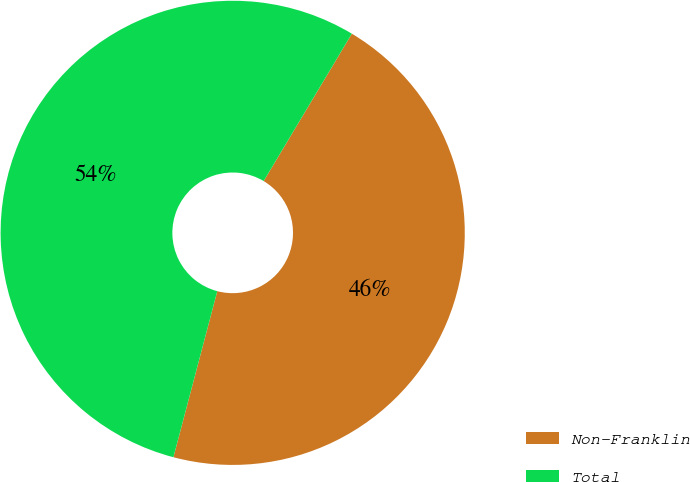<chart> <loc_0><loc_0><loc_500><loc_500><pie_chart><fcel>Non-Franklin<fcel>Total<nl><fcel>45.53%<fcel>54.47%<nl></chart> 